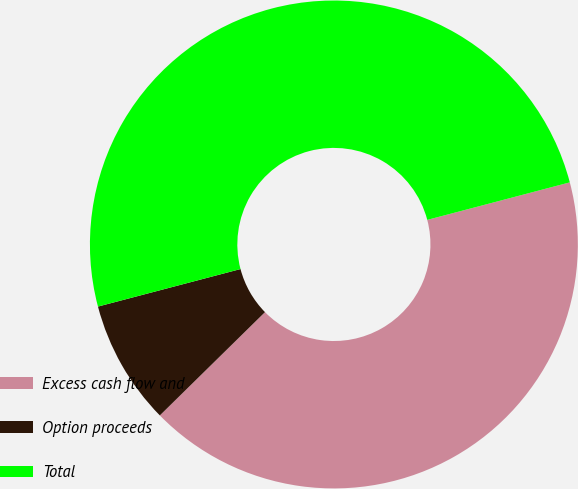Convert chart. <chart><loc_0><loc_0><loc_500><loc_500><pie_chart><fcel>Excess cash flow and<fcel>Option proceeds<fcel>Total<nl><fcel>41.74%<fcel>8.26%<fcel>50.0%<nl></chart> 